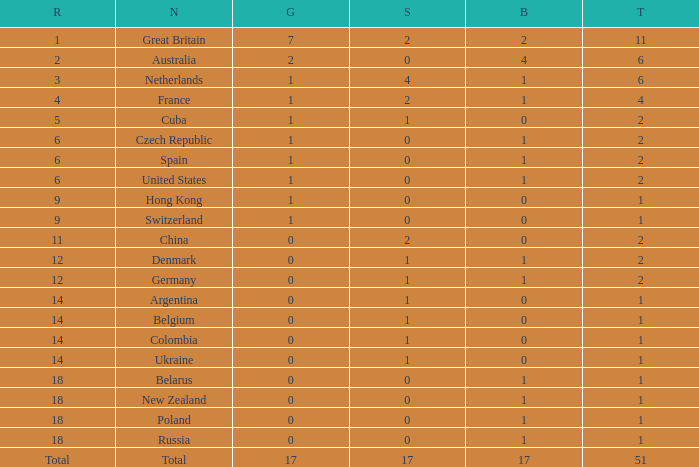Tell me the lowest gold for rank of 6 and total less than 2 None. 